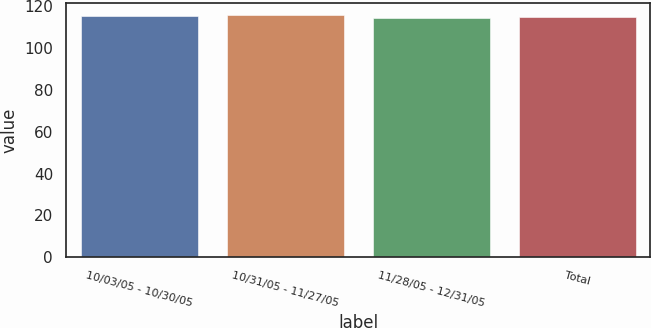<chart> <loc_0><loc_0><loc_500><loc_500><bar_chart><fcel>10/03/05 - 10/30/05<fcel>10/31/05 - 11/27/05<fcel>11/28/05 - 12/31/05<fcel>Total<nl><fcel>115.5<fcel>115.9<fcel>114.41<fcel>115.01<nl></chart> 